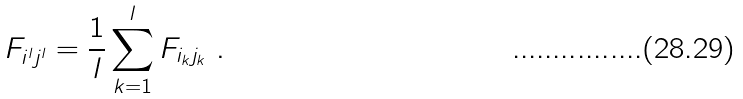Convert formula to latex. <formula><loc_0><loc_0><loc_500><loc_500>F _ { i ^ { l } j ^ { l } } = \frac { 1 } { l } \sum _ { k = 1 } ^ { l } F _ { i _ { k } j _ { k } } \ .</formula> 